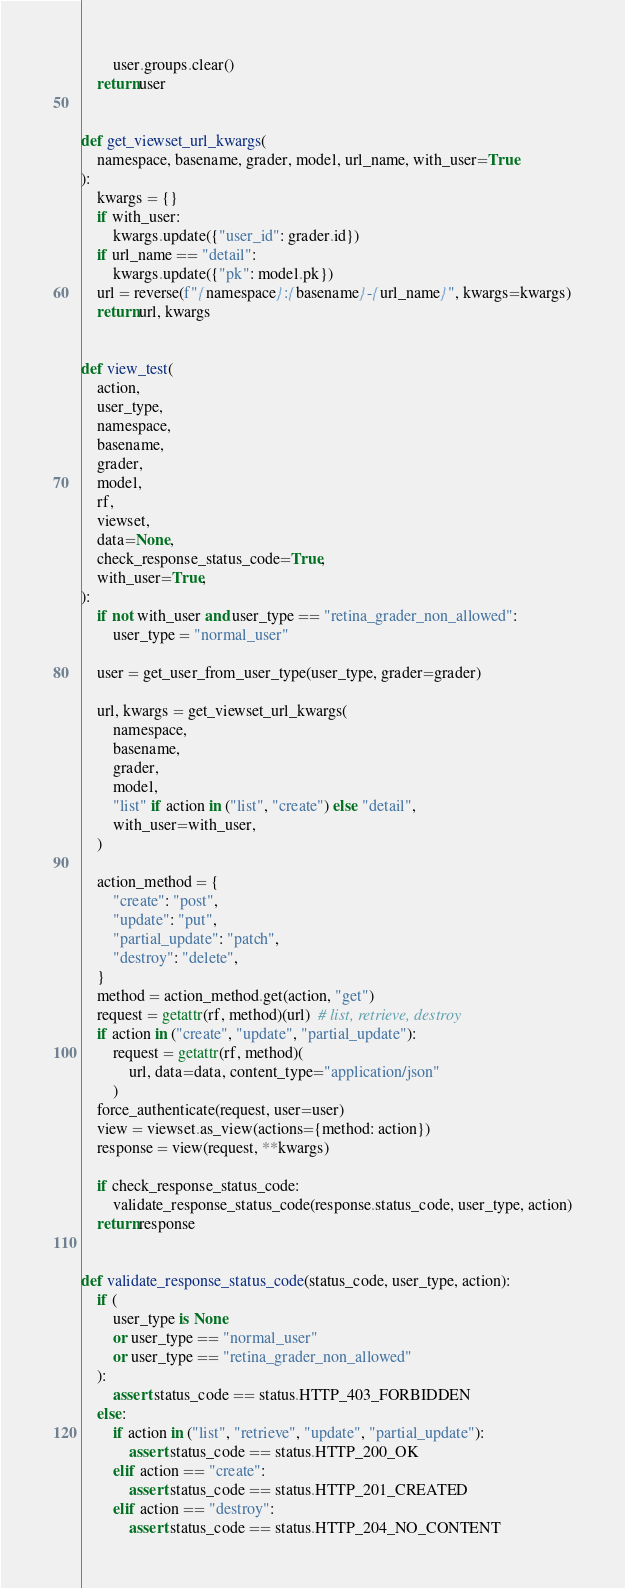Convert code to text. <code><loc_0><loc_0><loc_500><loc_500><_Python_>        user.groups.clear()
    return user


def get_viewset_url_kwargs(
    namespace, basename, grader, model, url_name, with_user=True
):
    kwargs = {}
    if with_user:
        kwargs.update({"user_id": grader.id})
    if url_name == "detail":
        kwargs.update({"pk": model.pk})
    url = reverse(f"{namespace}:{basename}-{url_name}", kwargs=kwargs)
    return url, kwargs


def view_test(
    action,
    user_type,
    namespace,
    basename,
    grader,
    model,
    rf,
    viewset,
    data=None,
    check_response_status_code=True,
    with_user=True,
):
    if not with_user and user_type == "retina_grader_non_allowed":
        user_type = "normal_user"

    user = get_user_from_user_type(user_type, grader=grader)

    url, kwargs = get_viewset_url_kwargs(
        namespace,
        basename,
        grader,
        model,
        "list" if action in ("list", "create") else "detail",
        with_user=with_user,
    )

    action_method = {
        "create": "post",
        "update": "put",
        "partial_update": "patch",
        "destroy": "delete",
    }
    method = action_method.get(action, "get")
    request = getattr(rf, method)(url)  # list, retrieve, destroy
    if action in ("create", "update", "partial_update"):
        request = getattr(rf, method)(
            url, data=data, content_type="application/json"
        )
    force_authenticate(request, user=user)
    view = viewset.as_view(actions={method: action})
    response = view(request, **kwargs)

    if check_response_status_code:
        validate_response_status_code(response.status_code, user_type, action)
    return response


def validate_response_status_code(status_code, user_type, action):
    if (
        user_type is None
        or user_type == "normal_user"
        or user_type == "retina_grader_non_allowed"
    ):
        assert status_code == status.HTTP_403_FORBIDDEN
    else:
        if action in ("list", "retrieve", "update", "partial_update"):
            assert status_code == status.HTTP_200_OK
        elif action == "create":
            assert status_code == status.HTTP_201_CREATED
        elif action == "destroy":
            assert status_code == status.HTTP_204_NO_CONTENT
</code> 